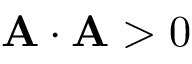<formula> <loc_0><loc_0><loc_500><loc_500>A \cdot A > 0</formula> 